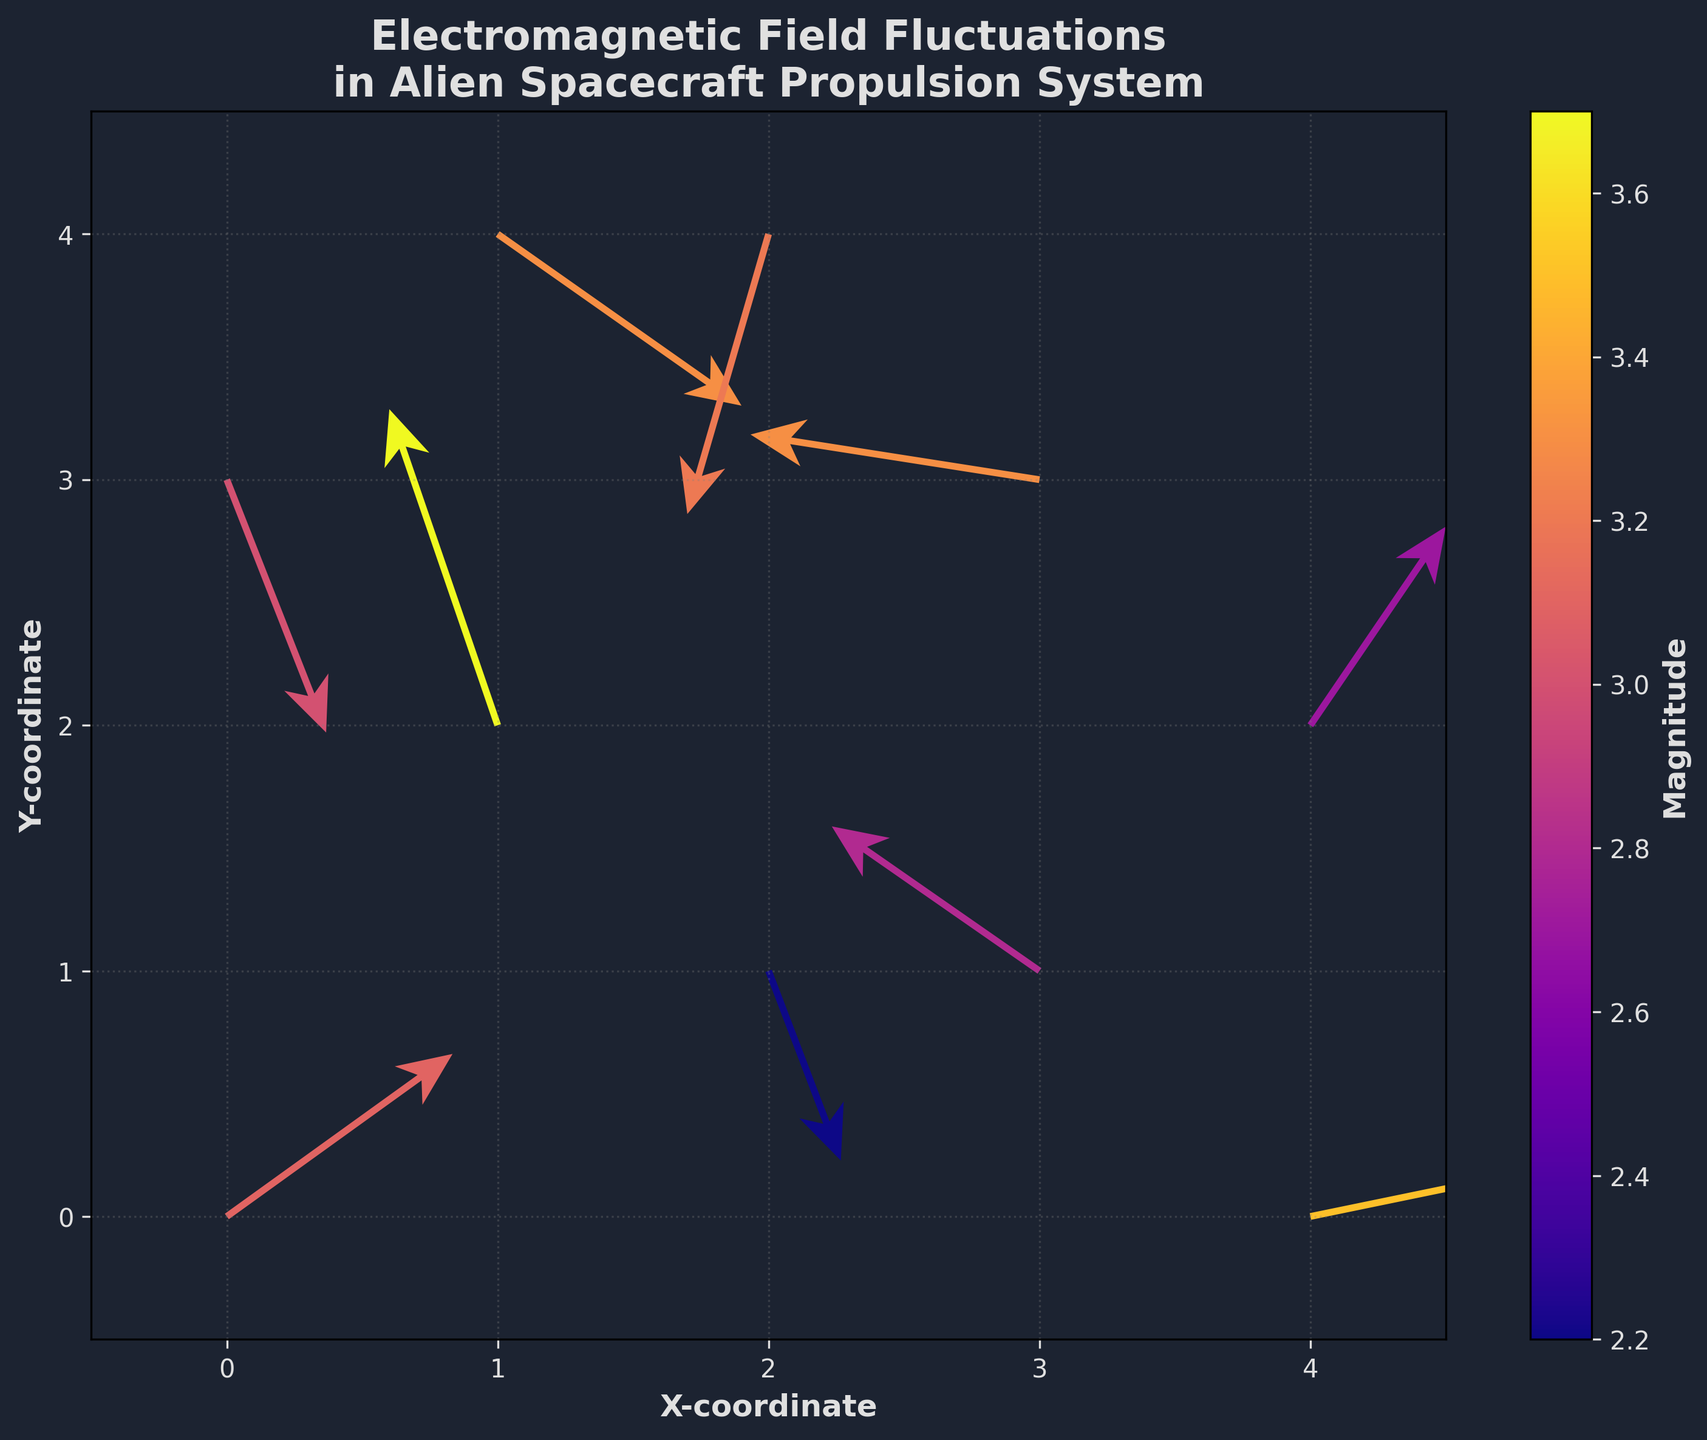What is the title of the plot? The title of the plot is usually displayed at the top center of the figure. In this case, it shows the description of the plot's focus.
Answer: "Electromagnetic Field Fluctuations in Alien Spacecraft Propulsion System" What is the color of the arrows in the plot? The arrows in the plot are indicated by a specific color that distinguishes them from other elements.
Answer: Light blue What labels are used for the x and y axes? The labels for the x and y axes can be found at the bottom and left side of the plot, respectively, showing the coordinate names.
Answer: "X-coordinate" and "Y-coordinate" How many data points (arrows) are in the plot? You can count the number of distinct arrows shown in the plot as the data points.
Answer: 10 What range is covered by the color bar on the right side of the plot? The color bar usually has a range indicating the magnitude values it represents and can be read from its labeled start and end.
Answer: Approximately 2 to 3.7 Which arrow has the highest magnitude and where is it located? You need to identify the arrow with the darkest color representing the highest magnitude and note its coordinates.
Answer: Arrow at coordinates (1, 2) What is the direction of the arrow at coordinates (4, 0)? The direction can be determined by looking at the orientation of the arrowhead starting from the base at coordinates (4, 0).
Answer: Mostly pointing to the right with some upward direction Which arrow has the most downward direction? To identify this, look for the arrow with the most significant negative v-component.
Answer: Arrow at coordinates (2, 4) Compare the magnitudes of the arrows at coordinates (1, 2) and (3, 1). Which one is greater? By examining the color hues at the given coordinates which represent the magnitude, we can identify which is greater.
Answer: The arrow at (1, 2) is greater What is the average magnitude of all the arrows in the plot? Calculate the sum of all magnitudes and then divide by the number of arrows to get the average value.
Answer: (3.1 + 3.7 + 2.2 + 3.3 + 3.3 + 2.7 + 3.2 + 3.5 + 2.8 + 3.0)/10 = 3.08 